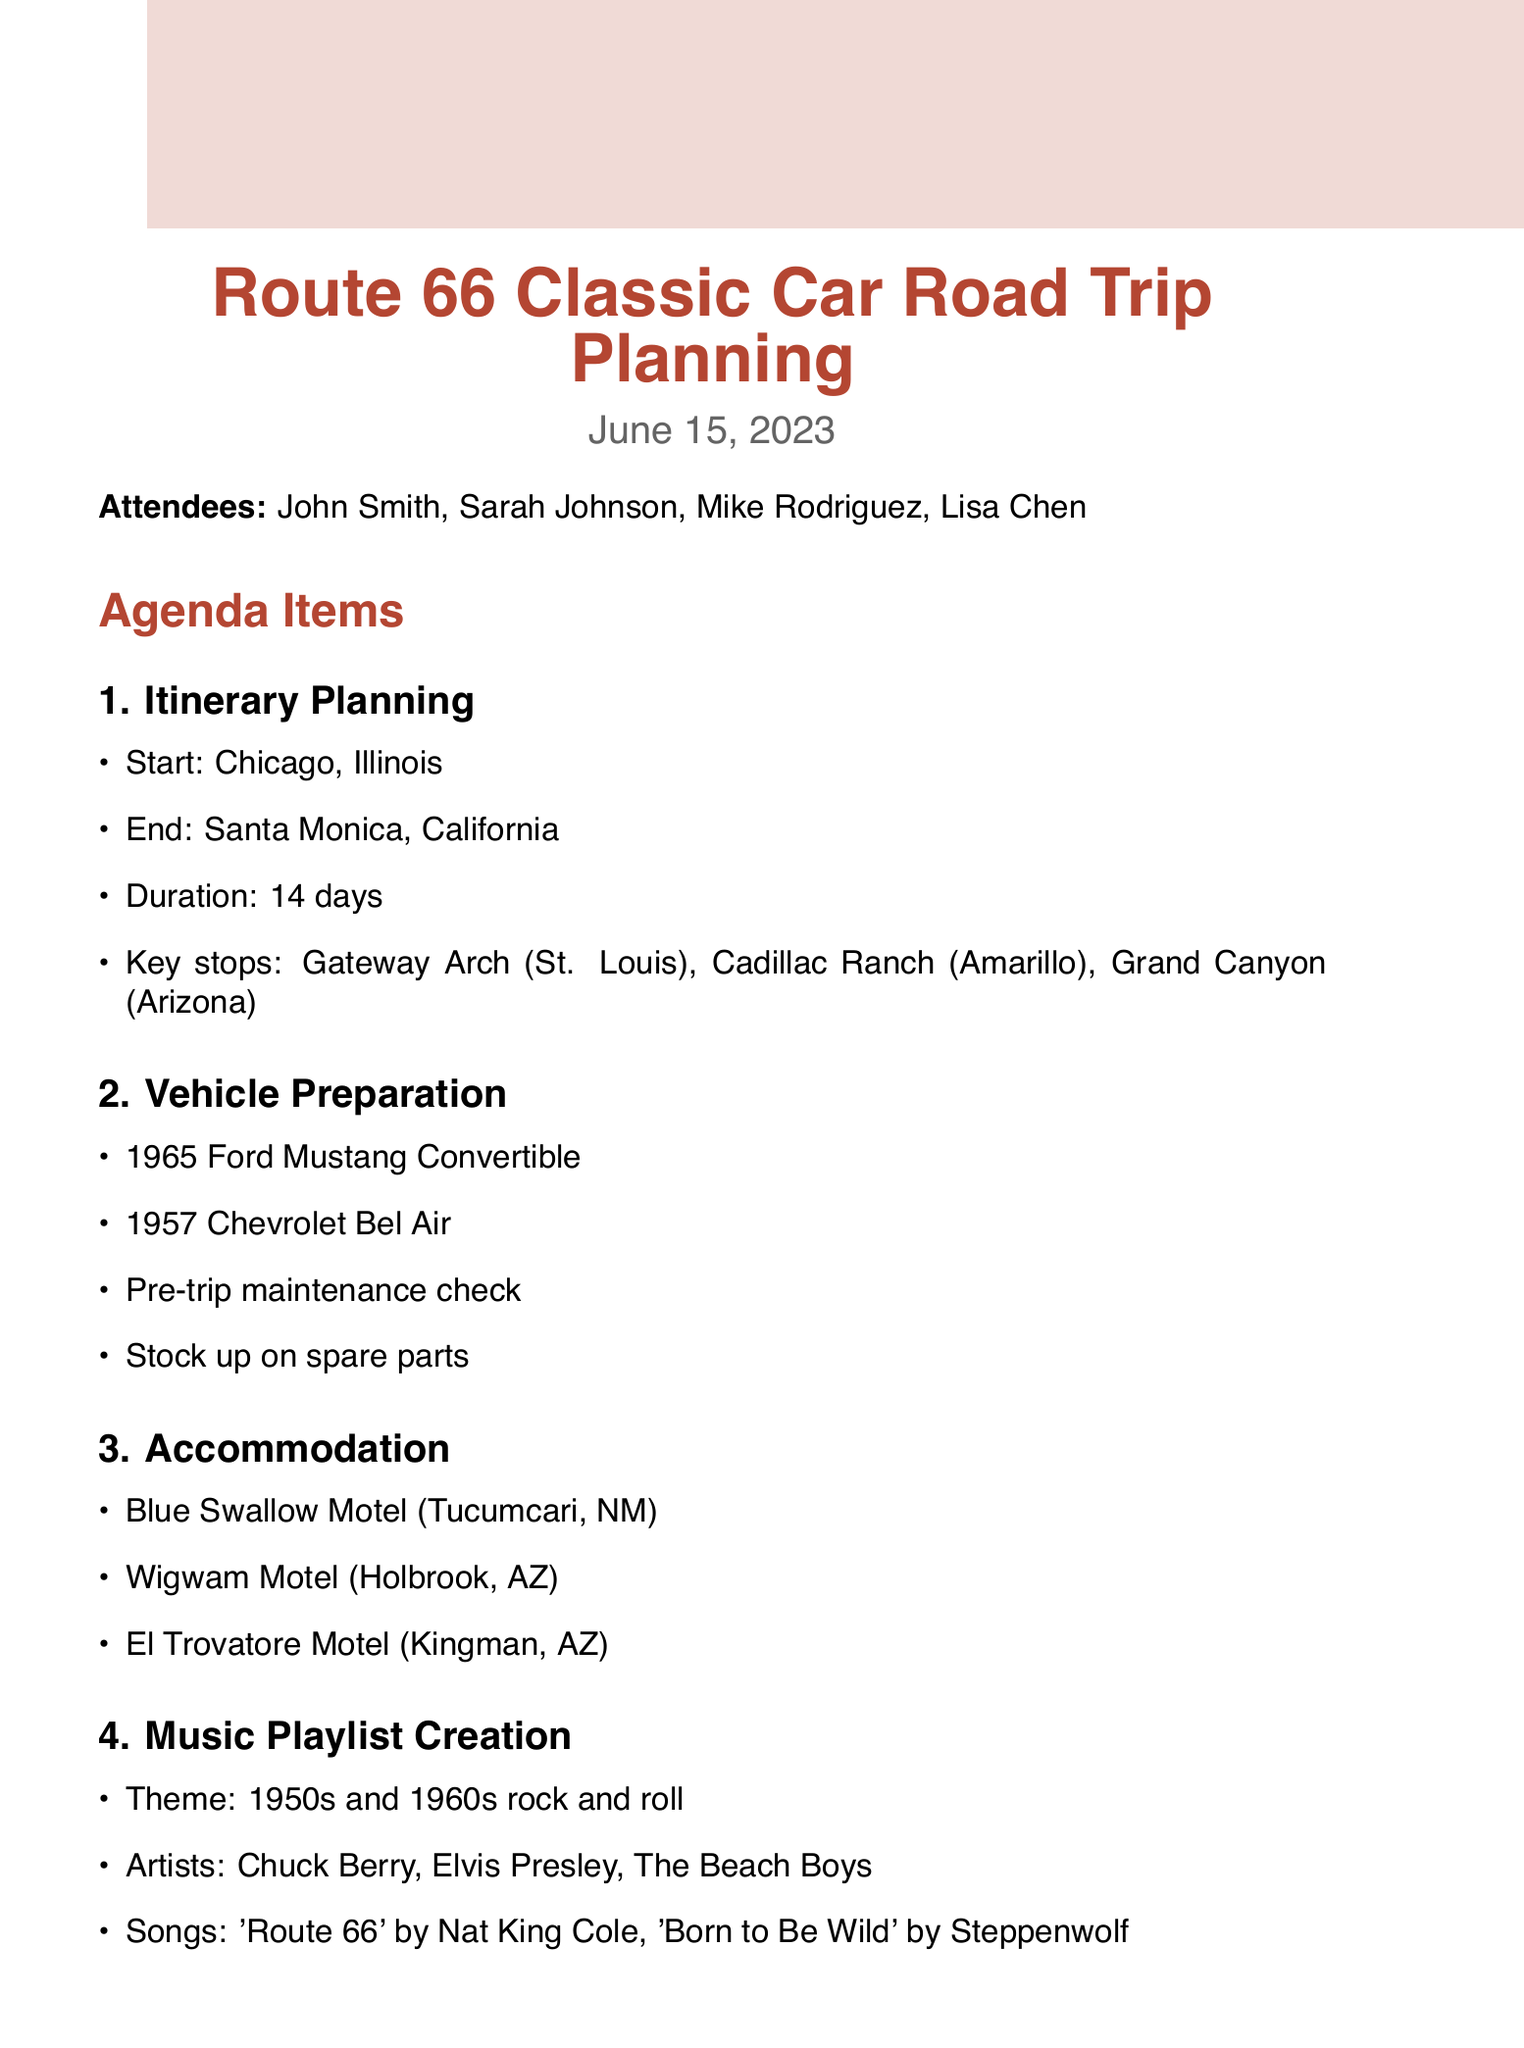What is the starting point of the trip? The starting point of the trip is mentioned in the itinerary planning section.
Answer: Chicago, Illinois What are the key stops during the road trip? Key stops are highlighted in the itinerary planning section.
Answer: Gateway Arch, Cadillac Ranch, Grand Canyon How many days will the trip last? The duration of the trip is explicitly provided in the document.
Answer: 14 days Which two classic cars are being prepared for the trip? The vehicle preparation section lists the classic cars being prepared.
Answer: 1965 Ford Mustang Convertible, 1957 Chevrolet Bel Air What theme is chosen for the music playlist? The music playlist creation section specifies the theme for the playlist.
Answer: 1950s and 1960s rock and roll Name one artist included in the music playlist. The music playlist creation section mentions specific artists.
Answer: Chuck Berry What is one accommodation mentioned for the trip? The accommodations listed in the document provide specific places to stay.
Answer: Blue Swallow Motel What is one action item for the group? The action items section outlines tasks that need to be completed before the trip.
Answer: Reserve accommodations 